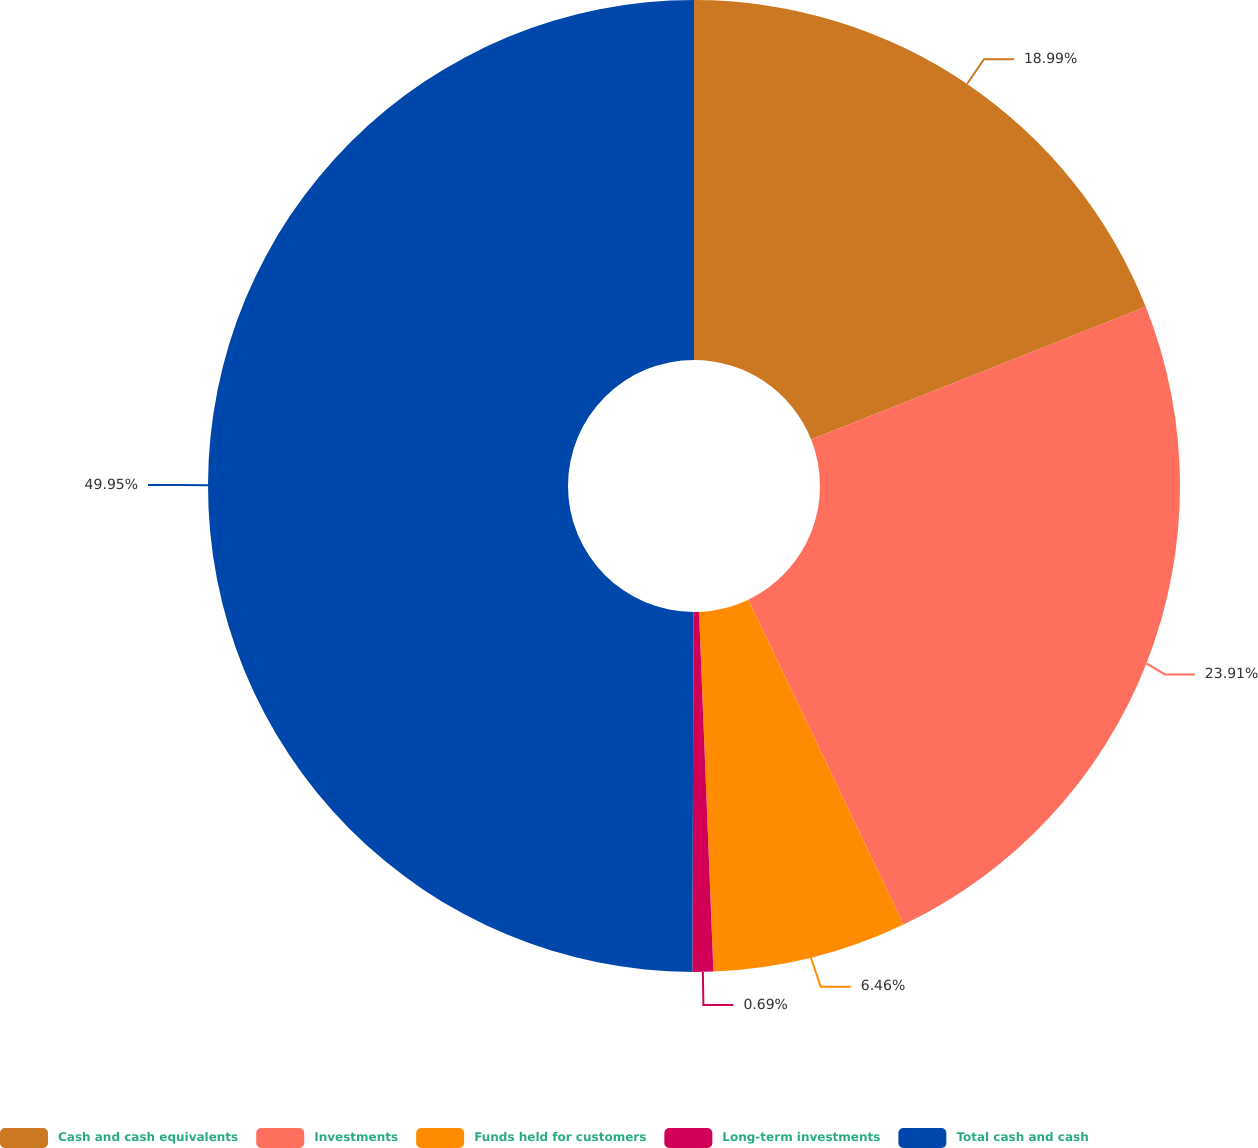Convert chart to OTSL. <chart><loc_0><loc_0><loc_500><loc_500><pie_chart><fcel>Cash and cash equivalents<fcel>Investments<fcel>Funds held for customers<fcel>Long-term investments<fcel>Total cash and cash<nl><fcel>18.99%<fcel>23.91%<fcel>6.46%<fcel>0.69%<fcel>49.94%<nl></chart> 